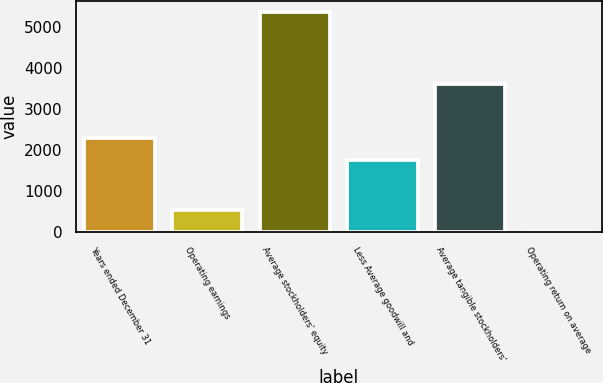Convert chart. <chart><loc_0><loc_0><loc_500><loc_500><bar_chart><fcel>Years ended December 31<fcel>Operating earnings<fcel>Average stockholders' equity<fcel>Less Average goodwill and<fcel>Average tangible stockholders'<fcel>Operating return on average<nl><fcel>2289.46<fcel>539.86<fcel>5368<fcel>1753<fcel>3615<fcel>3.4<nl></chart> 